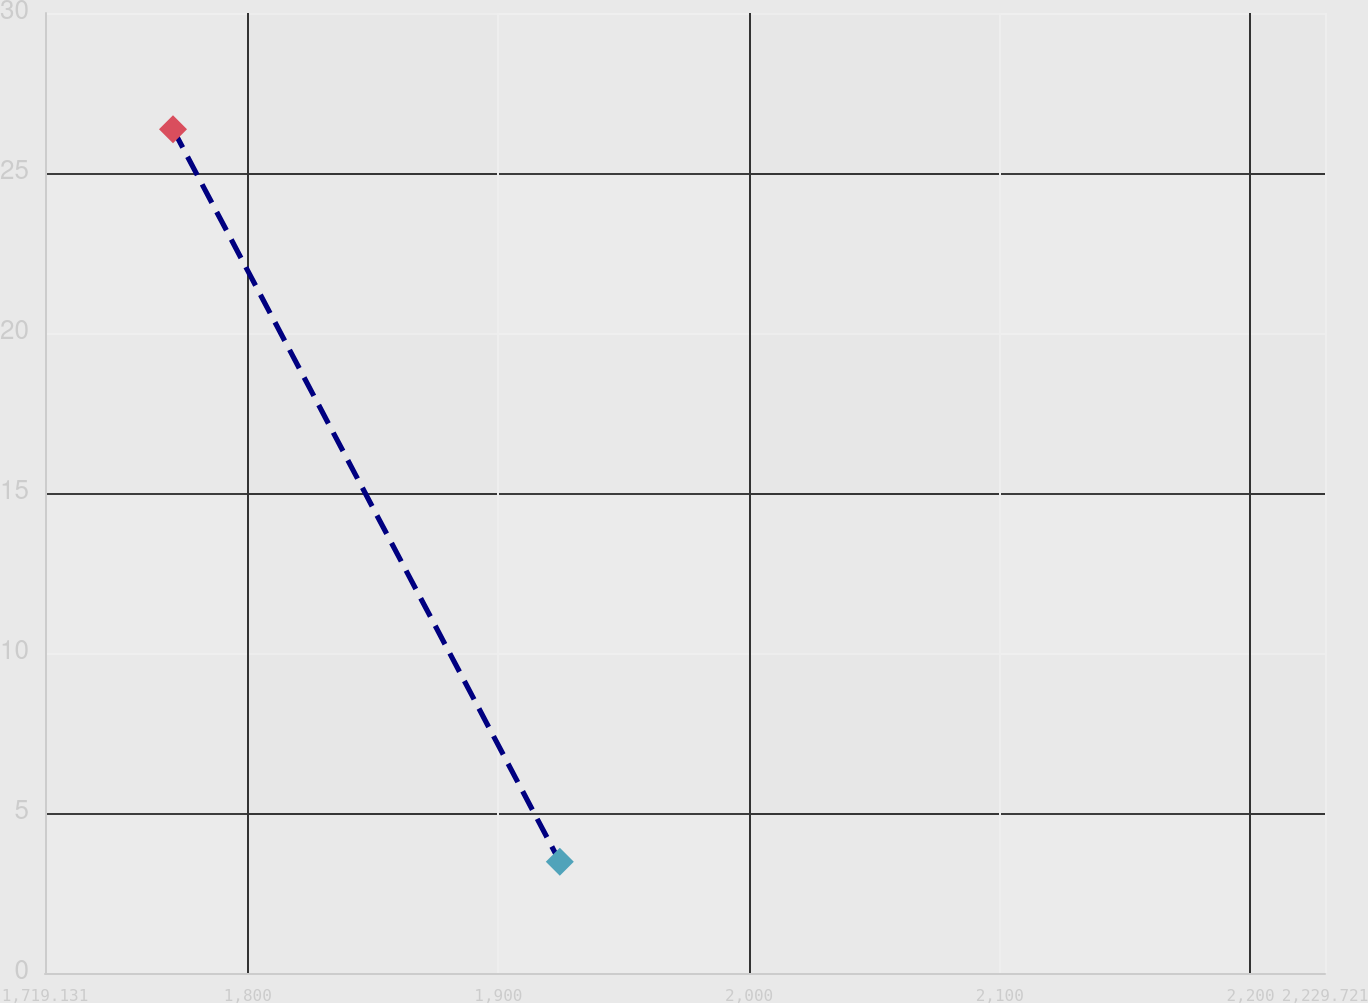<chart> <loc_0><loc_0><loc_500><loc_500><line_chart><ecel><fcel>Unnamed: 1<nl><fcel>1770.19<fcel>26.37<nl><fcel>1924.48<fcel>3.48<nl><fcel>2280.78<fcel>5.77<nl></chart> 